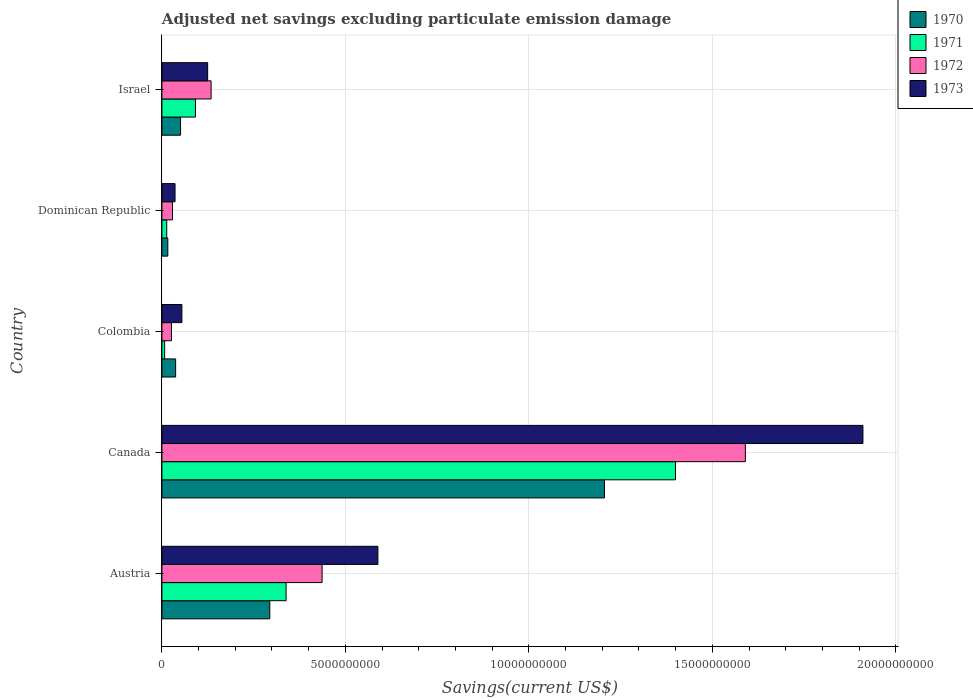How many different coloured bars are there?
Make the answer very short. 4. How many bars are there on the 5th tick from the top?
Offer a terse response. 4. How many bars are there on the 2nd tick from the bottom?
Your answer should be very brief. 4. In how many cases, is the number of bars for a given country not equal to the number of legend labels?
Provide a succinct answer. 0. What is the adjusted net savings in 1973 in Austria?
Make the answer very short. 5.89e+09. Across all countries, what is the maximum adjusted net savings in 1972?
Your response must be concise. 1.59e+1. Across all countries, what is the minimum adjusted net savings in 1973?
Your answer should be very brief. 3.58e+08. What is the total adjusted net savings in 1973 in the graph?
Your answer should be compact. 2.71e+1. What is the difference between the adjusted net savings in 1973 in Canada and that in Israel?
Give a very brief answer. 1.79e+1. What is the difference between the adjusted net savings in 1973 in Colombia and the adjusted net savings in 1972 in Canada?
Give a very brief answer. -1.54e+1. What is the average adjusted net savings in 1972 per country?
Make the answer very short. 4.43e+09. What is the difference between the adjusted net savings in 1971 and adjusted net savings in 1973 in Dominican Republic?
Provide a short and direct response. -2.27e+08. What is the ratio of the adjusted net savings in 1971 in Colombia to that in Israel?
Provide a succinct answer. 0.08. Is the adjusted net savings in 1973 in Colombia less than that in Dominican Republic?
Offer a terse response. No. Is the difference between the adjusted net savings in 1971 in Austria and Canada greater than the difference between the adjusted net savings in 1973 in Austria and Canada?
Make the answer very short. Yes. What is the difference between the highest and the second highest adjusted net savings in 1972?
Give a very brief answer. 1.15e+1. What is the difference between the highest and the lowest adjusted net savings in 1972?
Your answer should be compact. 1.56e+1. Is the sum of the adjusted net savings in 1970 in Colombia and Dominican Republic greater than the maximum adjusted net savings in 1973 across all countries?
Keep it short and to the point. No. Is it the case that in every country, the sum of the adjusted net savings in 1970 and adjusted net savings in 1972 is greater than the adjusted net savings in 1973?
Your answer should be compact. Yes. How many bars are there?
Offer a very short reply. 20. How many countries are there in the graph?
Keep it short and to the point. 5. What is the difference between two consecutive major ticks on the X-axis?
Offer a very short reply. 5.00e+09. Are the values on the major ticks of X-axis written in scientific E-notation?
Keep it short and to the point. No. Does the graph contain any zero values?
Make the answer very short. No. Does the graph contain grids?
Your response must be concise. Yes. Where does the legend appear in the graph?
Keep it short and to the point. Top right. What is the title of the graph?
Provide a short and direct response. Adjusted net savings excluding particulate emission damage. Does "2001" appear as one of the legend labels in the graph?
Keep it short and to the point. No. What is the label or title of the X-axis?
Give a very brief answer. Savings(current US$). What is the Savings(current US$) of 1970 in Austria?
Keep it short and to the point. 2.94e+09. What is the Savings(current US$) of 1971 in Austria?
Make the answer very short. 3.38e+09. What is the Savings(current US$) in 1972 in Austria?
Provide a succinct answer. 4.37e+09. What is the Savings(current US$) of 1973 in Austria?
Your answer should be very brief. 5.89e+09. What is the Savings(current US$) in 1970 in Canada?
Provide a succinct answer. 1.21e+1. What is the Savings(current US$) of 1971 in Canada?
Ensure brevity in your answer.  1.40e+1. What is the Savings(current US$) of 1972 in Canada?
Give a very brief answer. 1.59e+1. What is the Savings(current US$) of 1973 in Canada?
Your answer should be very brief. 1.91e+1. What is the Savings(current US$) in 1970 in Colombia?
Give a very brief answer. 3.74e+08. What is the Savings(current US$) in 1971 in Colombia?
Ensure brevity in your answer.  7.46e+07. What is the Savings(current US$) in 1972 in Colombia?
Provide a succinct answer. 2.60e+08. What is the Savings(current US$) of 1973 in Colombia?
Your answer should be compact. 5.45e+08. What is the Savings(current US$) in 1970 in Dominican Republic?
Make the answer very short. 1.61e+08. What is the Savings(current US$) in 1971 in Dominican Republic?
Offer a very short reply. 1.32e+08. What is the Savings(current US$) in 1972 in Dominican Republic?
Offer a terse response. 2.89e+08. What is the Savings(current US$) of 1973 in Dominican Republic?
Provide a succinct answer. 3.58e+08. What is the Savings(current US$) of 1970 in Israel?
Provide a succinct answer. 5.08e+08. What is the Savings(current US$) in 1971 in Israel?
Ensure brevity in your answer.  9.14e+08. What is the Savings(current US$) in 1972 in Israel?
Offer a very short reply. 1.34e+09. What is the Savings(current US$) in 1973 in Israel?
Provide a succinct answer. 1.25e+09. Across all countries, what is the maximum Savings(current US$) in 1970?
Your answer should be very brief. 1.21e+1. Across all countries, what is the maximum Savings(current US$) in 1971?
Provide a succinct answer. 1.40e+1. Across all countries, what is the maximum Savings(current US$) of 1972?
Offer a terse response. 1.59e+1. Across all countries, what is the maximum Savings(current US$) in 1973?
Provide a succinct answer. 1.91e+1. Across all countries, what is the minimum Savings(current US$) of 1970?
Give a very brief answer. 1.61e+08. Across all countries, what is the minimum Savings(current US$) in 1971?
Your answer should be very brief. 7.46e+07. Across all countries, what is the minimum Savings(current US$) of 1972?
Give a very brief answer. 2.60e+08. Across all countries, what is the minimum Savings(current US$) of 1973?
Your response must be concise. 3.58e+08. What is the total Savings(current US$) of 1970 in the graph?
Your response must be concise. 1.60e+1. What is the total Savings(current US$) in 1971 in the graph?
Your answer should be compact. 1.85e+1. What is the total Savings(current US$) in 1972 in the graph?
Provide a short and direct response. 2.22e+1. What is the total Savings(current US$) of 1973 in the graph?
Your response must be concise. 2.71e+1. What is the difference between the Savings(current US$) of 1970 in Austria and that in Canada?
Provide a short and direct response. -9.12e+09. What is the difference between the Savings(current US$) in 1971 in Austria and that in Canada?
Keep it short and to the point. -1.06e+1. What is the difference between the Savings(current US$) of 1972 in Austria and that in Canada?
Provide a short and direct response. -1.15e+1. What is the difference between the Savings(current US$) of 1973 in Austria and that in Canada?
Your answer should be very brief. -1.32e+1. What is the difference between the Savings(current US$) of 1970 in Austria and that in Colombia?
Make the answer very short. 2.57e+09. What is the difference between the Savings(current US$) in 1971 in Austria and that in Colombia?
Provide a succinct answer. 3.31e+09. What is the difference between the Savings(current US$) in 1972 in Austria and that in Colombia?
Provide a short and direct response. 4.11e+09. What is the difference between the Savings(current US$) of 1973 in Austria and that in Colombia?
Offer a terse response. 5.34e+09. What is the difference between the Savings(current US$) of 1970 in Austria and that in Dominican Republic?
Your answer should be very brief. 2.78e+09. What is the difference between the Savings(current US$) of 1971 in Austria and that in Dominican Republic?
Provide a short and direct response. 3.25e+09. What is the difference between the Savings(current US$) of 1972 in Austria and that in Dominican Republic?
Your response must be concise. 4.08e+09. What is the difference between the Savings(current US$) in 1973 in Austria and that in Dominican Republic?
Provide a succinct answer. 5.53e+09. What is the difference between the Savings(current US$) of 1970 in Austria and that in Israel?
Offer a terse response. 2.43e+09. What is the difference between the Savings(current US$) in 1971 in Austria and that in Israel?
Provide a succinct answer. 2.47e+09. What is the difference between the Savings(current US$) of 1972 in Austria and that in Israel?
Your answer should be very brief. 3.02e+09. What is the difference between the Savings(current US$) of 1973 in Austria and that in Israel?
Offer a terse response. 4.64e+09. What is the difference between the Savings(current US$) of 1970 in Canada and that in Colombia?
Keep it short and to the point. 1.17e+1. What is the difference between the Savings(current US$) of 1971 in Canada and that in Colombia?
Provide a succinct answer. 1.39e+1. What is the difference between the Savings(current US$) in 1972 in Canada and that in Colombia?
Make the answer very short. 1.56e+1. What is the difference between the Savings(current US$) in 1973 in Canada and that in Colombia?
Make the answer very short. 1.86e+1. What is the difference between the Savings(current US$) of 1970 in Canada and that in Dominican Republic?
Offer a very short reply. 1.19e+1. What is the difference between the Savings(current US$) in 1971 in Canada and that in Dominican Republic?
Ensure brevity in your answer.  1.39e+1. What is the difference between the Savings(current US$) in 1972 in Canada and that in Dominican Republic?
Keep it short and to the point. 1.56e+1. What is the difference between the Savings(current US$) of 1973 in Canada and that in Dominican Republic?
Your answer should be very brief. 1.87e+1. What is the difference between the Savings(current US$) of 1970 in Canada and that in Israel?
Give a very brief answer. 1.16e+1. What is the difference between the Savings(current US$) in 1971 in Canada and that in Israel?
Your answer should be very brief. 1.31e+1. What is the difference between the Savings(current US$) in 1972 in Canada and that in Israel?
Your answer should be very brief. 1.46e+1. What is the difference between the Savings(current US$) of 1973 in Canada and that in Israel?
Offer a very short reply. 1.79e+1. What is the difference between the Savings(current US$) of 1970 in Colombia and that in Dominican Republic?
Your answer should be compact. 2.13e+08. What is the difference between the Savings(current US$) of 1971 in Colombia and that in Dominican Republic?
Your answer should be very brief. -5.69e+07. What is the difference between the Savings(current US$) of 1972 in Colombia and that in Dominican Republic?
Offer a terse response. -2.84e+07. What is the difference between the Savings(current US$) of 1973 in Colombia and that in Dominican Republic?
Your answer should be compact. 1.87e+08. What is the difference between the Savings(current US$) of 1970 in Colombia and that in Israel?
Your answer should be very brief. -1.34e+08. What is the difference between the Savings(current US$) in 1971 in Colombia and that in Israel?
Provide a succinct answer. -8.40e+08. What is the difference between the Savings(current US$) in 1972 in Colombia and that in Israel?
Ensure brevity in your answer.  -1.08e+09. What is the difference between the Savings(current US$) in 1973 in Colombia and that in Israel?
Your answer should be compact. -7.02e+08. What is the difference between the Savings(current US$) in 1970 in Dominican Republic and that in Israel?
Provide a succinct answer. -3.47e+08. What is the difference between the Savings(current US$) in 1971 in Dominican Republic and that in Israel?
Make the answer very short. -7.83e+08. What is the difference between the Savings(current US$) in 1972 in Dominican Republic and that in Israel?
Make the answer very short. -1.05e+09. What is the difference between the Savings(current US$) in 1973 in Dominican Republic and that in Israel?
Keep it short and to the point. -8.89e+08. What is the difference between the Savings(current US$) of 1970 in Austria and the Savings(current US$) of 1971 in Canada?
Ensure brevity in your answer.  -1.11e+1. What is the difference between the Savings(current US$) of 1970 in Austria and the Savings(current US$) of 1972 in Canada?
Provide a succinct answer. -1.30e+1. What is the difference between the Savings(current US$) of 1970 in Austria and the Savings(current US$) of 1973 in Canada?
Offer a very short reply. -1.62e+1. What is the difference between the Savings(current US$) of 1971 in Austria and the Savings(current US$) of 1972 in Canada?
Your answer should be compact. -1.25e+1. What is the difference between the Savings(current US$) in 1971 in Austria and the Savings(current US$) in 1973 in Canada?
Your response must be concise. -1.57e+1. What is the difference between the Savings(current US$) in 1972 in Austria and the Savings(current US$) in 1973 in Canada?
Ensure brevity in your answer.  -1.47e+1. What is the difference between the Savings(current US$) of 1970 in Austria and the Savings(current US$) of 1971 in Colombia?
Your response must be concise. 2.87e+09. What is the difference between the Savings(current US$) of 1970 in Austria and the Savings(current US$) of 1972 in Colombia?
Offer a very short reply. 2.68e+09. What is the difference between the Savings(current US$) in 1970 in Austria and the Savings(current US$) in 1973 in Colombia?
Your answer should be compact. 2.40e+09. What is the difference between the Savings(current US$) in 1971 in Austria and the Savings(current US$) in 1972 in Colombia?
Your answer should be compact. 3.12e+09. What is the difference between the Savings(current US$) in 1971 in Austria and the Savings(current US$) in 1973 in Colombia?
Offer a very short reply. 2.84e+09. What is the difference between the Savings(current US$) in 1972 in Austria and the Savings(current US$) in 1973 in Colombia?
Your answer should be compact. 3.82e+09. What is the difference between the Savings(current US$) in 1970 in Austria and the Savings(current US$) in 1971 in Dominican Republic?
Keep it short and to the point. 2.81e+09. What is the difference between the Savings(current US$) of 1970 in Austria and the Savings(current US$) of 1972 in Dominican Republic?
Your answer should be compact. 2.65e+09. What is the difference between the Savings(current US$) in 1970 in Austria and the Savings(current US$) in 1973 in Dominican Republic?
Your answer should be very brief. 2.58e+09. What is the difference between the Savings(current US$) of 1971 in Austria and the Savings(current US$) of 1972 in Dominican Republic?
Offer a very short reply. 3.10e+09. What is the difference between the Savings(current US$) of 1971 in Austria and the Savings(current US$) of 1973 in Dominican Republic?
Your answer should be very brief. 3.03e+09. What is the difference between the Savings(current US$) in 1972 in Austria and the Savings(current US$) in 1973 in Dominican Republic?
Provide a short and direct response. 4.01e+09. What is the difference between the Savings(current US$) of 1970 in Austria and the Savings(current US$) of 1971 in Israel?
Your answer should be very brief. 2.03e+09. What is the difference between the Savings(current US$) of 1970 in Austria and the Savings(current US$) of 1972 in Israel?
Your response must be concise. 1.60e+09. What is the difference between the Savings(current US$) of 1970 in Austria and the Savings(current US$) of 1973 in Israel?
Make the answer very short. 1.69e+09. What is the difference between the Savings(current US$) of 1971 in Austria and the Savings(current US$) of 1972 in Israel?
Provide a succinct answer. 2.04e+09. What is the difference between the Savings(current US$) in 1971 in Austria and the Savings(current US$) in 1973 in Israel?
Your answer should be very brief. 2.14e+09. What is the difference between the Savings(current US$) of 1972 in Austria and the Savings(current US$) of 1973 in Israel?
Your response must be concise. 3.12e+09. What is the difference between the Savings(current US$) of 1970 in Canada and the Savings(current US$) of 1971 in Colombia?
Offer a very short reply. 1.20e+1. What is the difference between the Savings(current US$) of 1970 in Canada and the Savings(current US$) of 1972 in Colombia?
Ensure brevity in your answer.  1.18e+1. What is the difference between the Savings(current US$) in 1970 in Canada and the Savings(current US$) in 1973 in Colombia?
Keep it short and to the point. 1.15e+1. What is the difference between the Savings(current US$) in 1971 in Canada and the Savings(current US$) in 1972 in Colombia?
Ensure brevity in your answer.  1.37e+1. What is the difference between the Savings(current US$) of 1971 in Canada and the Savings(current US$) of 1973 in Colombia?
Keep it short and to the point. 1.35e+1. What is the difference between the Savings(current US$) of 1972 in Canada and the Savings(current US$) of 1973 in Colombia?
Your answer should be compact. 1.54e+1. What is the difference between the Savings(current US$) in 1970 in Canada and the Savings(current US$) in 1971 in Dominican Republic?
Provide a succinct answer. 1.19e+1. What is the difference between the Savings(current US$) of 1970 in Canada and the Savings(current US$) of 1972 in Dominican Republic?
Offer a terse response. 1.18e+1. What is the difference between the Savings(current US$) of 1970 in Canada and the Savings(current US$) of 1973 in Dominican Republic?
Offer a terse response. 1.17e+1. What is the difference between the Savings(current US$) of 1971 in Canada and the Savings(current US$) of 1972 in Dominican Republic?
Provide a short and direct response. 1.37e+1. What is the difference between the Savings(current US$) of 1971 in Canada and the Savings(current US$) of 1973 in Dominican Republic?
Ensure brevity in your answer.  1.36e+1. What is the difference between the Savings(current US$) of 1972 in Canada and the Savings(current US$) of 1973 in Dominican Republic?
Ensure brevity in your answer.  1.55e+1. What is the difference between the Savings(current US$) of 1970 in Canada and the Savings(current US$) of 1971 in Israel?
Give a very brief answer. 1.11e+1. What is the difference between the Savings(current US$) of 1970 in Canada and the Savings(current US$) of 1972 in Israel?
Ensure brevity in your answer.  1.07e+1. What is the difference between the Savings(current US$) in 1970 in Canada and the Savings(current US$) in 1973 in Israel?
Keep it short and to the point. 1.08e+1. What is the difference between the Savings(current US$) in 1971 in Canada and the Savings(current US$) in 1972 in Israel?
Keep it short and to the point. 1.27e+1. What is the difference between the Savings(current US$) of 1971 in Canada and the Savings(current US$) of 1973 in Israel?
Your response must be concise. 1.27e+1. What is the difference between the Savings(current US$) in 1972 in Canada and the Savings(current US$) in 1973 in Israel?
Your answer should be compact. 1.47e+1. What is the difference between the Savings(current US$) of 1970 in Colombia and the Savings(current US$) of 1971 in Dominican Republic?
Offer a very short reply. 2.42e+08. What is the difference between the Savings(current US$) in 1970 in Colombia and the Savings(current US$) in 1972 in Dominican Republic?
Offer a very short reply. 8.52e+07. What is the difference between the Savings(current US$) of 1970 in Colombia and the Savings(current US$) of 1973 in Dominican Republic?
Ensure brevity in your answer.  1.57e+07. What is the difference between the Savings(current US$) in 1971 in Colombia and the Savings(current US$) in 1972 in Dominican Republic?
Your response must be concise. -2.14e+08. What is the difference between the Savings(current US$) of 1971 in Colombia and the Savings(current US$) of 1973 in Dominican Republic?
Offer a terse response. -2.84e+08. What is the difference between the Savings(current US$) of 1972 in Colombia and the Savings(current US$) of 1973 in Dominican Republic?
Provide a succinct answer. -9.79e+07. What is the difference between the Savings(current US$) of 1970 in Colombia and the Savings(current US$) of 1971 in Israel?
Offer a very short reply. -5.40e+08. What is the difference between the Savings(current US$) of 1970 in Colombia and the Savings(current US$) of 1972 in Israel?
Keep it short and to the point. -9.67e+08. What is the difference between the Savings(current US$) of 1970 in Colombia and the Savings(current US$) of 1973 in Israel?
Your answer should be very brief. -8.73e+08. What is the difference between the Savings(current US$) in 1971 in Colombia and the Savings(current US$) in 1972 in Israel?
Offer a terse response. -1.27e+09. What is the difference between the Savings(current US$) of 1971 in Colombia and the Savings(current US$) of 1973 in Israel?
Make the answer very short. -1.17e+09. What is the difference between the Savings(current US$) in 1972 in Colombia and the Savings(current US$) in 1973 in Israel?
Give a very brief answer. -9.87e+08. What is the difference between the Savings(current US$) of 1970 in Dominican Republic and the Savings(current US$) of 1971 in Israel?
Offer a terse response. -7.53e+08. What is the difference between the Savings(current US$) of 1970 in Dominican Republic and the Savings(current US$) of 1972 in Israel?
Your answer should be compact. -1.18e+09. What is the difference between the Savings(current US$) of 1970 in Dominican Republic and the Savings(current US$) of 1973 in Israel?
Provide a succinct answer. -1.09e+09. What is the difference between the Savings(current US$) of 1971 in Dominican Republic and the Savings(current US$) of 1972 in Israel?
Your answer should be compact. -1.21e+09. What is the difference between the Savings(current US$) of 1971 in Dominican Republic and the Savings(current US$) of 1973 in Israel?
Make the answer very short. -1.12e+09. What is the difference between the Savings(current US$) in 1972 in Dominican Republic and the Savings(current US$) in 1973 in Israel?
Make the answer very short. -9.58e+08. What is the average Savings(current US$) in 1970 per country?
Offer a very short reply. 3.21e+09. What is the average Savings(current US$) in 1971 per country?
Offer a very short reply. 3.70e+09. What is the average Savings(current US$) of 1972 per country?
Give a very brief answer. 4.43e+09. What is the average Savings(current US$) of 1973 per country?
Ensure brevity in your answer.  5.43e+09. What is the difference between the Savings(current US$) in 1970 and Savings(current US$) in 1971 in Austria?
Offer a very short reply. -4.45e+08. What is the difference between the Savings(current US$) of 1970 and Savings(current US$) of 1972 in Austria?
Your response must be concise. -1.43e+09. What is the difference between the Savings(current US$) of 1970 and Savings(current US$) of 1973 in Austria?
Give a very brief answer. -2.95e+09. What is the difference between the Savings(current US$) in 1971 and Savings(current US$) in 1972 in Austria?
Your response must be concise. -9.81e+08. What is the difference between the Savings(current US$) in 1971 and Savings(current US$) in 1973 in Austria?
Make the answer very short. -2.50e+09. What is the difference between the Savings(current US$) in 1972 and Savings(current US$) in 1973 in Austria?
Your response must be concise. -1.52e+09. What is the difference between the Savings(current US$) of 1970 and Savings(current US$) of 1971 in Canada?
Your answer should be very brief. -1.94e+09. What is the difference between the Savings(current US$) in 1970 and Savings(current US$) in 1972 in Canada?
Your answer should be very brief. -3.84e+09. What is the difference between the Savings(current US$) of 1970 and Savings(current US$) of 1973 in Canada?
Make the answer very short. -7.04e+09. What is the difference between the Savings(current US$) in 1971 and Savings(current US$) in 1972 in Canada?
Provide a succinct answer. -1.90e+09. What is the difference between the Savings(current US$) of 1971 and Savings(current US$) of 1973 in Canada?
Offer a very short reply. -5.11e+09. What is the difference between the Savings(current US$) in 1972 and Savings(current US$) in 1973 in Canada?
Offer a terse response. -3.20e+09. What is the difference between the Savings(current US$) of 1970 and Savings(current US$) of 1971 in Colombia?
Your answer should be very brief. 2.99e+08. What is the difference between the Savings(current US$) in 1970 and Savings(current US$) in 1972 in Colombia?
Ensure brevity in your answer.  1.14e+08. What is the difference between the Savings(current US$) in 1970 and Savings(current US$) in 1973 in Colombia?
Provide a succinct answer. -1.71e+08. What is the difference between the Savings(current US$) in 1971 and Savings(current US$) in 1972 in Colombia?
Provide a succinct answer. -1.86e+08. What is the difference between the Savings(current US$) in 1971 and Savings(current US$) in 1973 in Colombia?
Make the answer very short. -4.70e+08. What is the difference between the Savings(current US$) in 1972 and Savings(current US$) in 1973 in Colombia?
Provide a short and direct response. -2.85e+08. What is the difference between the Savings(current US$) of 1970 and Savings(current US$) of 1971 in Dominican Republic?
Give a very brief answer. 2.96e+07. What is the difference between the Savings(current US$) of 1970 and Savings(current US$) of 1972 in Dominican Republic?
Offer a very short reply. -1.28e+08. What is the difference between the Savings(current US$) in 1970 and Savings(current US$) in 1973 in Dominican Republic?
Ensure brevity in your answer.  -1.97e+08. What is the difference between the Savings(current US$) of 1971 and Savings(current US$) of 1972 in Dominican Republic?
Your response must be concise. -1.57e+08. What is the difference between the Savings(current US$) in 1971 and Savings(current US$) in 1973 in Dominican Republic?
Your answer should be very brief. -2.27e+08. What is the difference between the Savings(current US$) in 1972 and Savings(current US$) in 1973 in Dominican Republic?
Give a very brief answer. -6.95e+07. What is the difference between the Savings(current US$) in 1970 and Savings(current US$) in 1971 in Israel?
Ensure brevity in your answer.  -4.06e+08. What is the difference between the Savings(current US$) in 1970 and Savings(current US$) in 1972 in Israel?
Ensure brevity in your answer.  -8.33e+08. What is the difference between the Savings(current US$) in 1970 and Savings(current US$) in 1973 in Israel?
Provide a short and direct response. -7.39e+08. What is the difference between the Savings(current US$) of 1971 and Savings(current US$) of 1972 in Israel?
Provide a short and direct response. -4.27e+08. What is the difference between the Savings(current US$) of 1971 and Savings(current US$) of 1973 in Israel?
Ensure brevity in your answer.  -3.33e+08. What is the difference between the Savings(current US$) in 1972 and Savings(current US$) in 1973 in Israel?
Your answer should be compact. 9.40e+07. What is the ratio of the Savings(current US$) in 1970 in Austria to that in Canada?
Give a very brief answer. 0.24. What is the ratio of the Savings(current US$) of 1971 in Austria to that in Canada?
Offer a very short reply. 0.24. What is the ratio of the Savings(current US$) of 1972 in Austria to that in Canada?
Ensure brevity in your answer.  0.27. What is the ratio of the Savings(current US$) of 1973 in Austria to that in Canada?
Provide a succinct answer. 0.31. What is the ratio of the Savings(current US$) in 1970 in Austria to that in Colombia?
Your answer should be very brief. 7.86. What is the ratio of the Savings(current US$) of 1971 in Austria to that in Colombia?
Provide a short and direct response. 45.37. What is the ratio of the Savings(current US$) in 1972 in Austria to that in Colombia?
Make the answer very short. 16.77. What is the ratio of the Savings(current US$) of 1973 in Austria to that in Colombia?
Give a very brief answer. 10.8. What is the ratio of the Savings(current US$) in 1970 in Austria to that in Dominican Republic?
Offer a terse response. 18.25. What is the ratio of the Savings(current US$) in 1971 in Austria to that in Dominican Republic?
Ensure brevity in your answer.  25.73. What is the ratio of the Savings(current US$) of 1972 in Austria to that in Dominican Republic?
Your answer should be very brief. 15.12. What is the ratio of the Savings(current US$) in 1973 in Austria to that in Dominican Republic?
Your answer should be compact. 16.43. What is the ratio of the Savings(current US$) in 1970 in Austria to that in Israel?
Offer a terse response. 5.79. What is the ratio of the Savings(current US$) of 1971 in Austria to that in Israel?
Your answer should be very brief. 3.7. What is the ratio of the Savings(current US$) of 1972 in Austria to that in Israel?
Your response must be concise. 3.26. What is the ratio of the Savings(current US$) in 1973 in Austria to that in Israel?
Provide a short and direct response. 4.72. What is the ratio of the Savings(current US$) of 1970 in Canada to that in Colombia?
Provide a short and direct response. 32.26. What is the ratio of the Savings(current US$) of 1971 in Canada to that in Colombia?
Offer a very short reply. 187.59. What is the ratio of the Savings(current US$) in 1972 in Canada to that in Colombia?
Give a very brief answer. 61.09. What is the ratio of the Savings(current US$) in 1973 in Canada to that in Colombia?
Your answer should be very brief. 35.07. What is the ratio of the Savings(current US$) in 1970 in Canada to that in Dominican Republic?
Your answer should be compact. 74.87. What is the ratio of the Savings(current US$) in 1971 in Canada to that in Dominican Republic?
Your answer should be compact. 106.4. What is the ratio of the Savings(current US$) of 1972 in Canada to that in Dominican Republic?
Your answer should be compact. 55.08. What is the ratio of the Savings(current US$) in 1973 in Canada to that in Dominican Republic?
Your answer should be compact. 53.33. What is the ratio of the Savings(current US$) of 1970 in Canada to that in Israel?
Keep it short and to the point. 23.75. What is the ratio of the Savings(current US$) in 1971 in Canada to that in Israel?
Give a very brief answer. 15.31. What is the ratio of the Savings(current US$) of 1972 in Canada to that in Israel?
Ensure brevity in your answer.  11.86. What is the ratio of the Savings(current US$) of 1973 in Canada to that in Israel?
Your answer should be compact. 15.32. What is the ratio of the Savings(current US$) in 1970 in Colombia to that in Dominican Republic?
Provide a succinct answer. 2.32. What is the ratio of the Savings(current US$) of 1971 in Colombia to that in Dominican Republic?
Offer a very short reply. 0.57. What is the ratio of the Savings(current US$) of 1972 in Colombia to that in Dominican Republic?
Give a very brief answer. 0.9. What is the ratio of the Savings(current US$) of 1973 in Colombia to that in Dominican Republic?
Make the answer very short. 1.52. What is the ratio of the Savings(current US$) of 1970 in Colombia to that in Israel?
Make the answer very short. 0.74. What is the ratio of the Savings(current US$) in 1971 in Colombia to that in Israel?
Provide a short and direct response. 0.08. What is the ratio of the Savings(current US$) of 1972 in Colombia to that in Israel?
Your response must be concise. 0.19. What is the ratio of the Savings(current US$) of 1973 in Colombia to that in Israel?
Give a very brief answer. 0.44. What is the ratio of the Savings(current US$) of 1970 in Dominican Republic to that in Israel?
Your answer should be very brief. 0.32. What is the ratio of the Savings(current US$) in 1971 in Dominican Republic to that in Israel?
Your response must be concise. 0.14. What is the ratio of the Savings(current US$) in 1972 in Dominican Republic to that in Israel?
Offer a terse response. 0.22. What is the ratio of the Savings(current US$) of 1973 in Dominican Republic to that in Israel?
Keep it short and to the point. 0.29. What is the difference between the highest and the second highest Savings(current US$) of 1970?
Offer a very short reply. 9.12e+09. What is the difference between the highest and the second highest Savings(current US$) in 1971?
Offer a very short reply. 1.06e+1. What is the difference between the highest and the second highest Savings(current US$) in 1972?
Your answer should be very brief. 1.15e+1. What is the difference between the highest and the second highest Savings(current US$) in 1973?
Make the answer very short. 1.32e+1. What is the difference between the highest and the lowest Savings(current US$) of 1970?
Provide a succinct answer. 1.19e+1. What is the difference between the highest and the lowest Savings(current US$) in 1971?
Your response must be concise. 1.39e+1. What is the difference between the highest and the lowest Savings(current US$) in 1972?
Offer a very short reply. 1.56e+1. What is the difference between the highest and the lowest Savings(current US$) in 1973?
Make the answer very short. 1.87e+1. 